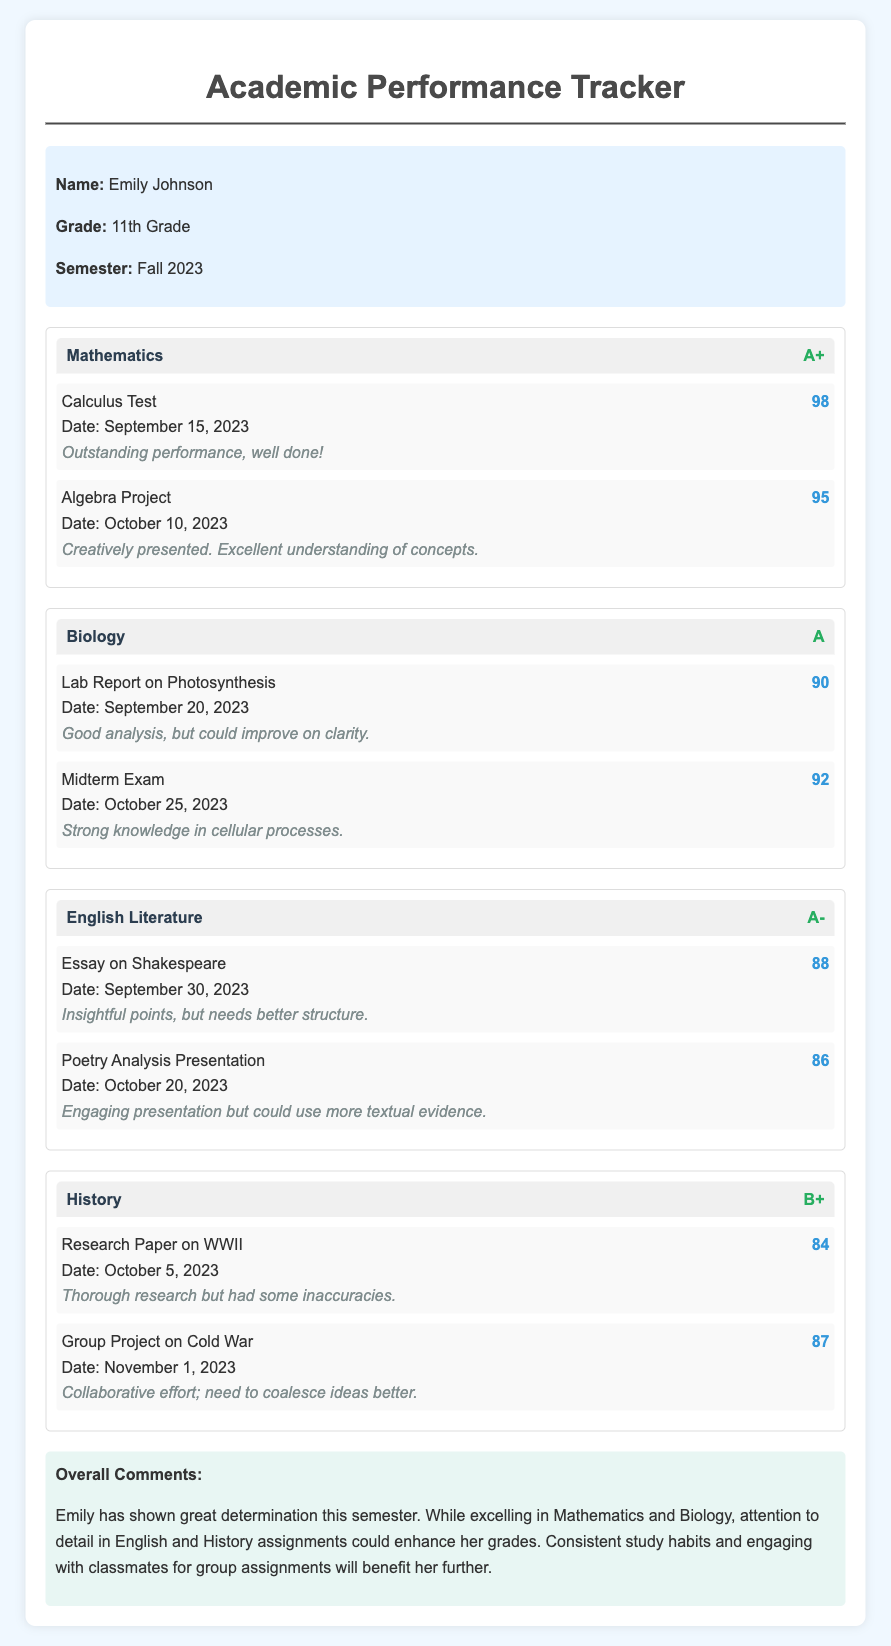What grade did Emily receive in Mathematics? The grade is listed next to the subject name in the document, which indicates her performance.
Answer: A+ What was Emily's score on the Calculus Test? The score is stated alongside the assignment title within the Mathematics section.
Answer: 98 What comments did the teacher make about the Lab Report on Photosynthesis? The comment for the assignment reveals the teacher's feedback on Emily's performance in Biology.
Answer: Good analysis, but could improve on clarity In which subject did Emily score the lowest? This requires comparing the grades across subjects and identifying the lowest one.
Answer: History What is Emily's average score for English Literature assignments? The average is calculated by taking the scores from the two assignments and finding the mean.
Answer: 87 What does the overall comment suggest Emily should improve on? This requires synthesizing the feedback from the overall comments section in the document.
Answer: Attention to detail What is the date of the Midterm Exam in Biology? The date is provided in the assignment details under the Biology section.
Answer: October 25, 2023 How many assignments were listed under the History subject? The number of assignments is detailed in the History section of the document.
Answer: 2 What grade did Emily achieve in Biology? The grade is shown in the header of the Biology subject section of the document.
Answer: A 